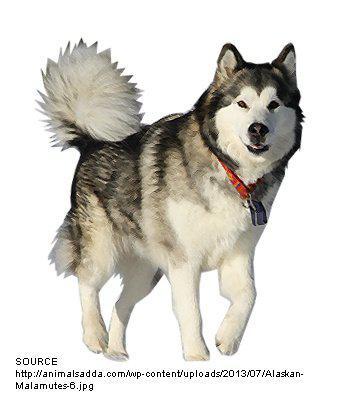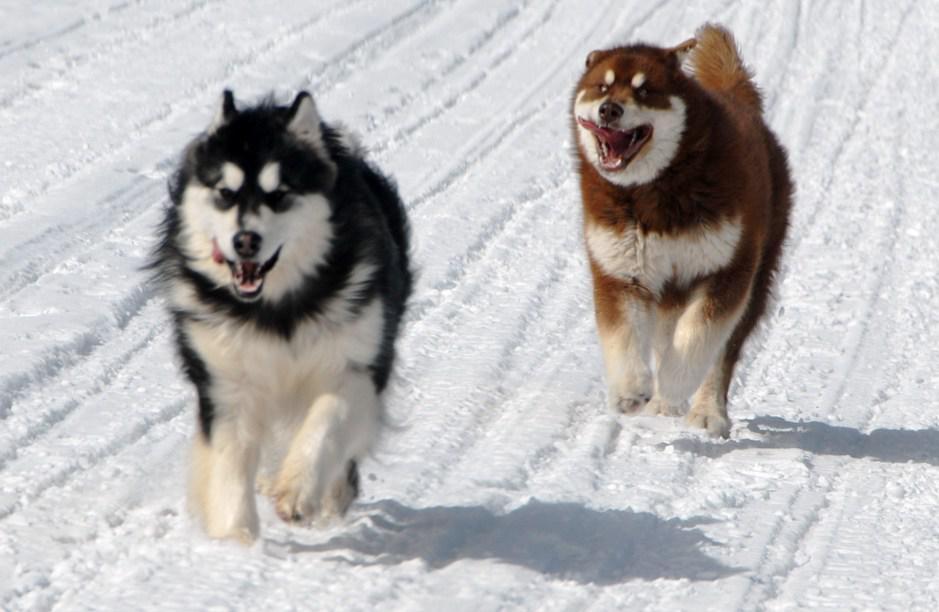The first image is the image on the left, the second image is the image on the right. Analyze the images presented: Is the assertion "In one image there is one dog, and in the other image there are two dogs that are the same breed." valid? Answer yes or no. Yes. The first image is the image on the left, the second image is the image on the right. Considering the images on both sides, is "The combined images include three husky dogs that are standing up and at least two dogs with their tongues hanging out of smiling mouths." valid? Answer yes or no. Yes. 